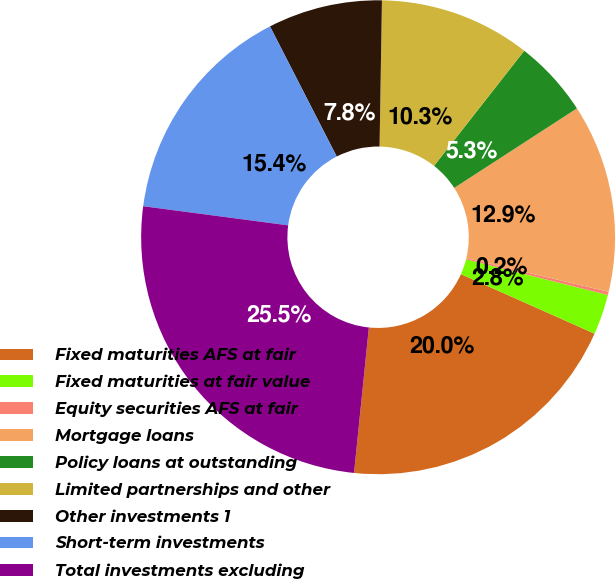Convert chart to OTSL. <chart><loc_0><loc_0><loc_500><loc_500><pie_chart><fcel>Fixed maturities AFS at fair<fcel>Fixed maturities at fair value<fcel>Equity securities AFS at fair<fcel>Mortgage loans<fcel>Policy loans at outstanding<fcel>Limited partnerships and other<fcel>Other investments 1<fcel>Short-term investments<fcel>Total investments excluding<nl><fcel>19.95%<fcel>2.75%<fcel>0.22%<fcel>12.85%<fcel>5.27%<fcel>10.32%<fcel>7.8%<fcel>15.37%<fcel>25.47%<nl></chart> 